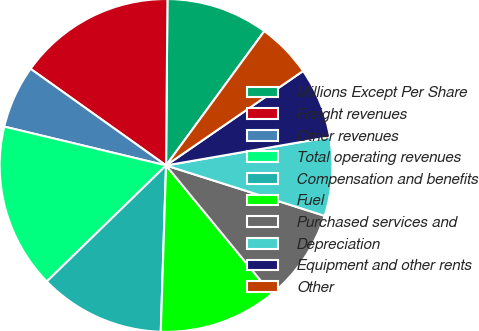<chart> <loc_0><loc_0><loc_500><loc_500><pie_chart><fcel>Millions Except Per Share<fcel>Freight revenues<fcel>Other revenues<fcel>Total operating revenues<fcel>Compensation and benefits<fcel>Fuel<fcel>Purchased services and<fcel>Depreciation<fcel>Equipment and other rents<fcel>Other<nl><fcel>9.92%<fcel>15.27%<fcel>6.11%<fcel>16.03%<fcel>12.21%<fcel>11.45%<fcel>9.16%<fcel>7.63%<fcel>6.87%<fcel>5.34%<nl></chart> 